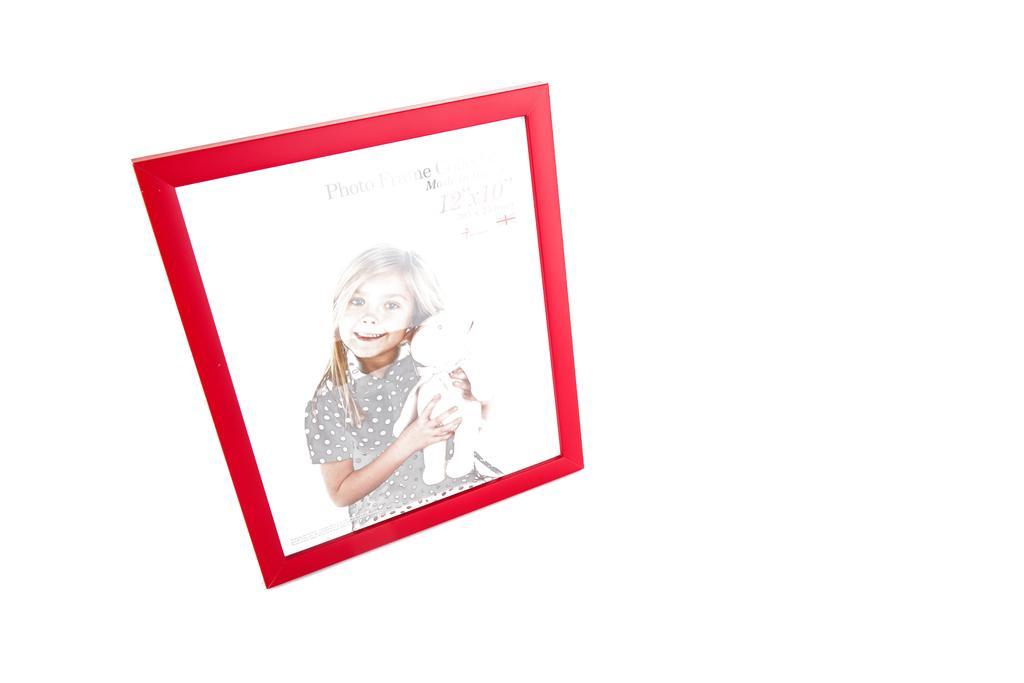Describe this image in one or two sentences. In this image I can see a red colour photo frame and I can see this frame contains the picture of a girl. I can see she is holding a white colour thing and on her face I can see the smile. On the top right side of the frame, I can see something is written and I can also see white colour in the background. 